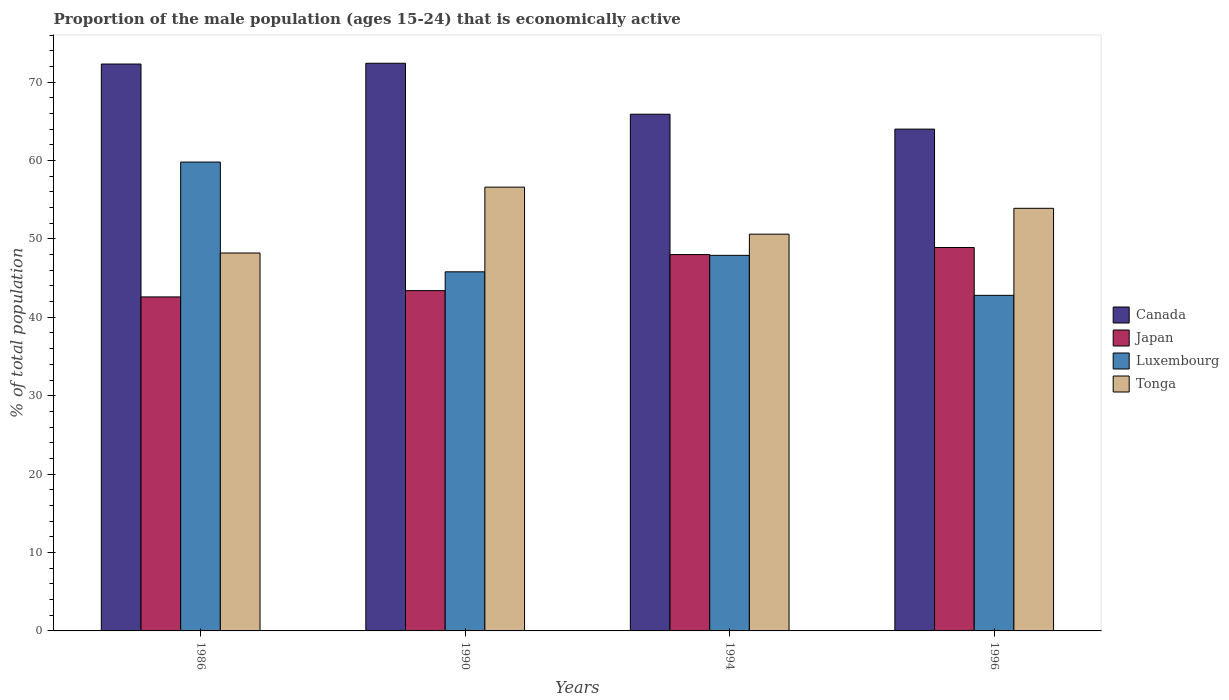Are the number of bars per tick equal to the number of legend labels?
Offer a terse response. Yes. Are the number of bars on each tick of the X-axis equal?
Ensure brevity in your answer.  Yes. What is the label of the 1st group of bars from the left?
Offer a terse response. 1986. What is the proportion of the male population that is economically active in Canada in 1994?
Provide a short and direct response. 65.9. Across all years, what is the maximum proportion of the male population that is economically active in Tonga?
Give a very brief answer. 56.6. Across all years, what is the minimum proportion of the male population that is economically active in Tonga?
Your answer should be very brief. 48.2. In which year was the proportion of the male population that is economically active in Canada maximum?
Offer a terse response. 1990. In which year was the proportion of the male population that is economically active in Luxembourg minimum?
Keep it short and to the point. 1996. What is the total proportion of the male population that is economically active in Canada in the graph?
Provide a short and direct response. 274.6. What is the difference between the proportion of the male population that is economically active in Japan in 1994 and that in 1996?
Your answer should be very brief. -0.9. What is the difference between the proportion of the male population that is economically active in Japan in 1986 and the proportion of the male population that is economically active in Tonga in 1994?
Give a very brief answer. -8. What is the average proportion of the male population that is economically active in Luxembourg per year?
Your answer should be very brief. 49.07. In the year 1996, what is the difference between the proportion of the male population that is economically active in Canada and proportion of the male population that is economically active in Tonga?
Keep it short and to the point. 10.1. In how many years, is the proportion of the male population that is economically active in Canada greater than 16 %?
Make the answer very short. 4. What is the ratio of the proportion of the male population that is economically active in Japan in 1986 to that in 1990?
Make the answer very short. 0.98. Is the proportion of the male population that is economically active in Canada in 1986 less than that in 1996?
Give a very brief answer. No. Is the difference between the proportion of the male population that is economically active in Canada in 1994 and 1996 greater than the difference between the proportion of the male population that is economically active in Tonga in 1994 and 1996?
Your answer should be very brief. Yes. What is the difference between the highest and the second highest proportion of the male population that is economically active in Luxembourg?
Provide a short and direct response. 11.9. What is the difference between the highest and the lowest proportion of the male population that is economically active in Canada?
Ensure brevity in your answer.  8.4. In how many years, is the proportion of the male population that is economically active in Luxembourg greater than the average proportion of the male population that is economically active in Luxembourg taken over all years?
Provide a succinct answer. 1. What does the 4th bar from the left in 1990 represents?
Offer a terse response. Tonga. What does the 4th bar from the right in 1990 represents?
Offer a terse response. Canada. Is it the case that in every year, the sum of the proportion of the male population that is economically active in Tonga and proportion of the male population that is economically active in Japan is greater than the proportion of the male population that is economically active in Luxembourg?
Your answer should be very brief. Yes. How many bars are there?
Give a very brief answer. 16. Are all the bars in the graph horizontal?
Provide a succinct answer. No. What is the difference between two consecutive major ticks on the Y-axis?
Give a very brief answer. 10. Are the values on the major ticks of Y-axis written in scientific E-notation?
Your answer should be very brief. No. Does the graph contain grids?
Offer a terse response. No. What is the title of the graph?
Ensure brevity in your answer.  Proportion of the male population (ages 15-24) that is economically active. What is the label or title of the X-axis?
Your answer should be very brief. Years. What is the label or title of the Y-axis?
Provide a short and direct response. % of total population. What is the % of total population in Canada in 1986?
Give a very brief answer. 72.3. What is the % of total population of Japan in 1986?
Ensure brevity in your answer.  42.6. What is the % of total population of Luxembourg in 1986?
Ensure brevity in your answer.  59.8. What is the % of total population of Tonga in 1986?
Give a very brief answer. 48.2. What is the % of total population in Canada in 1990?
Offer a very short reply. 72.4. What is the % of total population of Japan in 1990?
Keep it short and to the point. 43.4. What is the % of total population in Luxembourg in 1990?
Your answer should be very brief. 45.8. What is the % of total population of Tonga in 1990?
Your response must be concise. 56.6. What is the % of total population in Canada in 1994?
Give a very brief answer. 65.9. What is the % of total population in Luxembourg in 1994?
Your answer should be compact. 47.9. What is the % of total population in Tonga in 1994?
Keep it short and to the point. 50.6. What is the % of total population of Japan in 1996?
Your answer should be compact. 48.9. What is the % of total population of Luxembourg in 1996?
Make the answer very short. 42.8. What is the % of total population in Tonga in 1996?
Your response must be concise. 53.9. Across all years, what is the maximum % of total population of Canada?
Give a very brief answer. 72.4. Across all years, what is the maximum % of total population of Japan?
Provide a succinct answer. 48.9. Across all years, what is the maximum % of total population of Luxembourg?
Your response must be concise. 59.8. Across all years, what is the maximum % of total population in Tonga?
Your answer should be compact. 56.6. Across all years, what is the minimum % of total population in Canada?
Provide a succinct answer. 64. Across all years, what is the minimum % of total population of Japan?
Make the answer very short. 42.6. Across all years, what is the minimum % of total population in Luxembourg?
Offer a terse response. 42.8. Across all years, what is the minimum % of total population in Tonga?
Your response must be concise. 48.2. What is the total % of total population of Canada in the graph?
Make the answer very short. 274.6. What is the total % of total population of Japan in the graph?
Make the answer very short. 182.9. What is the total % of total population in Luxembourg in the graph?
Provide a succinct answer. 196.3. What is the total % of total population in Tonga in the graph?
Ensure brevity in your answer.  209.3. What is the difference between the % of total population in Canada in 1986 and that in 1990?
Your answer should be compact. -0.1. What is the difference between the % of total population in Tonga in 1986 and that in 1990?
Keep it short and to the point. -8.4. What is the difference between the % of total population in Japan in 1986 and that in 1994?
Provide a short and direct response. -5.4. What is the difference between the % of total population in Canada in 1986 and that in 1996?
Provide a succinct answer. 8.3. What is the difference between the % of total population of Luxembourg in 1986 and that in 1996?
Your answer should be very brief. 17. What is the difference between the % of total population of Canada in 1990 and that in 1994?
Your answer should be very brief. 6.5. What is the difference between the % of total population of Luxembourg in 1990 and that in 1994?
Your answer should be very brief. -2.1. What is the difference between the % of total population in Tonga in 1990 and that in 1994?
Your answer should be very brief. 6. What is the difference between the % of total population in Japan in 1990 and that in 1996?
Your response must be concise. -5.5. What is the difference between the % of total population in Luxembourg in 1990 and that in 1996?
Provide a succinct answer. 3. What is the difference between the % of total population in Japan in 1994 and that in 1996?
Offer a terse response. -0.9. What is the difference between the % of total population in Luxembourg in 1994 and that in 1996?
Your answer should be compact. 5.1. What is the difference between the % of total population in Canada in 1986 and the % of total population in Japan in 1990?
Give a very brief answer. 28.9. What is the difference between the % of total population of Canada in 1986 and the % of total population of Tonga in 1990?
Your answer should be very brief. 15.7. What is the difference between the % of total population of Luxembourg in 1986 and the % of total population of Tonga in 1990?
Keep it short and to the point. 3.2. What is the difference between the % of total population in Canada in 1986 and the % of total population in Japan in 1994?
Offer a terse response. 24.3. What is the difference between the % of total population of Canada in 1986 and the % of total population of Luxembourg in 1994?
Make the answer very short. 24.4. What is the difference between the % of total population of Canada in 1986 and the % of total population of Tonga in 1994?
Offer a terse response. 21.7. What is the difference between the % of total population of Japan in 1986 and the % of total population of Tonga in 1994?
Offer a terse response. -8. What is the difference between the % of total population of Canada in 1986 and the % of total population of Japan in 1996?
Your answer should be compact. 23.4. What is the difference between the % of total population in Canada in 1986 and the % of total population in Luxembourg in 1996?
Your answer should be compact. 29.5. What is the difference between the % of total population in Japan in 1986 and the % of total population in Luxembourg in 1996?
Provide a succinct answer. -0.2. What is the difference between the % of total population in Japan in 1986 and the % of total population in Tonga in 1996?
Provide a short and direct response. -11.3. What is the difference between the % of total population in Canada in 1990 and the % of total population in Japan in 1994?
Offer a very short reply. 24.4. What is the difference between the % of total population of Canada in 1990 and the % of total population of Luxembourg in 1994?
Provide a succinct answer. 24.5. What is the difference between the % of total population in Canada in 1990 and the % of total population in Tonga in 1994?
Keep it short and to the point. 21.8. What is the difference between the % of total population of Canada in 1990 and the % of total population of Japan in 1996?
Ensure brevity in your answer.  23.5. What is the difference between the % of total population of Canada in 1990 and the % of total population of Luxembourg in 1996?
Keep it short and to the point. 29.6. What is the difference between the % of total population of Canada in 1990 and the % of total population of Tonga in 1996?
Your answer should be compact. 18.5. What is the difference between the % of total population of Luxembourg in 1990 and the % of total population of Tonga in 1996?
Your answer should be compact. -8.1. What is the difference between the % of total population of Canada in 1994 and the % of total population of Luxembourg in 1996?
Your answer should be very brief. 23.1. What is the difference between the % of total population in Japan in 1994 and the % of total population in Luxembourg in 1996?
Your response must be concise. 5.2. What is the difference between the % of total population in Japan in 1994 and the % of total population in Tonga in 1996?
Offer a terse response. -5.9. What is the difference between the % of total population of Luxembourg in 1994 and the % of total population of Tonga in 1996?
Provide a short and direct response. -6. What is the average % of total population in Canada per year?
Keep it short and to the point. 68.65. What is the average % of total population in Japan per year?
Ensure brevity in your answer.  45.73. What is the average % of total population in Luxembourg per year?
Ensure brevity in your answer.  49.08. What is the average % of total population in Tonga per year?
Your response must be concise. 52.33. In the year 1986, what is the difference between the % of total population in Canada and % of total population in Japan?
Offer a terse response. 29.7. In the year 1986, what is the difference between the % of total population of Canada and % of total population of Luxembourg?
Give a very brief answer. 12.5. In the year 1986, what is the difference between the % of total population in Canada and % of total population in Tonga?
Give a very brief answer. 24.1. In the year 1986, what is the difference between the % of total population of Japan and % of total population of Luxembourg?
Provide a succinct answer. -17.2. In the year 1986, what is the difference between the % of total population of Luxembourg and % of total population of Tonga?
Offer a very short reply. 11.6. In the year 1990, what is the difference between the % of total population in Canada and % of total population in Luxembourg?
Your answer should be very brief. 26.6. In the year 1990, what is the difference between the % of total population of Japan and % of total population of Luxembourg?
Give a very brief answer. -2.4. In the year 1990, what is the difference between the % of total population of Luxembourg and % of total population of Tonga?
Keep it short and to the point. -10.8. In the year 1994, what is the difference between the % of total population in Canada and % of total population in Japan?
Offer a terse response. 17.9. In the year 1994, what is the difference between the % of total population of Canada and % of total population of Tonga?
Give a very brief answer. 15.3. In the year 1994, what is the difference between the % of total population in Japan and % of total population in Luxembourg?
Offer a very short reply. 0.1. In the year 1994, what is the difference between the % of total population of Luxembourg and % of total population of Tonga?
Provide a short and direct response. -2.7. In the year 1996, what is the difference between the % of total population in Canada and % of total population in Luxembourg?
Your answer should be compact. 21.2. In the year 1996, what is the difference between the % of total population in Japan and % of total population in Luxembourg?
Give a very brief answer. 6.1. What is the ratio of the % of total population of Japan in 1986 to that in 1990?
Offer a very short reply. 0.98. What is the ratio of the % of total population in Luxembourg in 1986 to that in 1990?
Give a very brief answer. 1.31. What is the ratio of the % of total population of Tonga in 1986 to that in 1990?
Offer a terse response. 0.85. What is the ratio of the % of total population in Canada in 1986 to that in 1994?
Your answer should be compact. 1.1. What is the ratio of the % of total population in Japan in 1986 to that in 1994?
Ensure brevity in your answer.  0.89. What is the ratio of the % of total population in Luxembourg in 1986 to that in 1994?
Give a very brief answer. 1.25. What is the ratio of the % of total population in Tonga in 1986 to that in 1994?
Provide a succinct answer. 0.95. What is the ratio of the % of total population in Canada in 1986 to that in 1996?
Offer a terse response. 1.13. What is the ratio of the % of total population of Japan in 1986 to that in 1996?
Provide a short and direct response. 0.87. What is the ratio of the % of total population in Luxembourg in 1986 to that in 1996?
Keep it short and to the point. 1.4. What is the ratio of the % of total population in Tonga in 1986 to that in 1996?
Keep it short and to the point. 0.89. What is the ratio of the % of total population in Canada in 1990 to that in 1994?
Your answer should be very brief. 1.1. What is the ratio of the % of total population of Japan in 1990 to that in 1994?
Your answer should be very brief. 0.9. What is the ratio of the % of total population of Luxembourg in 1990 to that in 1994?
Ensure brevity in your answer.  0.96. What is the ratio of the % of total population of Tonga in 1990 to that in 1994?
Give a very brief answer. 1.12. What is the ratio of the % of total population of Canada in 1990 to that in 1996?
Ensure brevity in your answer.  1.13. What is the ratio of the % of total population in Japan in 1990 to that in 1996?
Make the answer very short. 0.89. What is the ratio of the % of total population of Luxembourg in 1990 to that in 1996?
Provide a succinct answer. 1.07. What is the ratio of the % of total population of Tonga in 1990 to that in 1996?
Your answer should be compact. 1.05. What is the ratio of the % of total population of Canada in 1994 to that in 1996?
Provide a short and direct response. 1.03. What is the ratio of the % of total population in Japan in 1994 to that in 1996?
Make the answer very short. 0.98. What is the ratio of the % of total population in Luxembourg in 1994 to that in 1996?
Make the answer very short. 1.12. What is the ratio of the % of total population in Tonga in 1994 to that in 1996?
Offer a very short reply. 0.94. What is the difference between the highest and the second highest % of total population in Canada?
Offer a terse response. 0.1. What is the difference between the highest and the lowest % of total population of Japan?
Your response must be concise. 6.3. What is the difference between the highest and the lowest % of total population of Luxembourg?
Your answer should be compact. 17. 